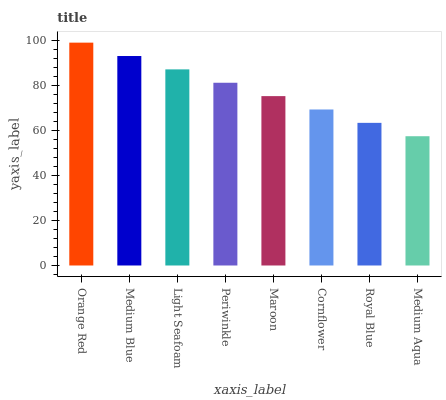Is Medium Aqua the minimum?
Answer yes or no. Yes. Is Orange Red the maximum?
Answer yes or no. Yes. Is Medium Blue the minimum?
Answer yes or no. No. Is Medium Blue the maximum?
Answer yes or no. No. Is Orange Red greater than Medium Blue?
Answer yes or no. Yes. Is Medium Blue less than Orange Red?
Answer yes or no. Yes. Is Medium Blue greater than Orange Red?
Answer yes or no. No. Is Orange Red less than Medium Blue?
Answer yes or no. No. Is Periwinkle the high median?
Answer yes or no. Yes. Is Maroon the low median?
Answer yes or no. Yes. Is Maroon the high median?
Answer yes or no. No. Is Cornflower the low median?
Answer yes or no. No. 